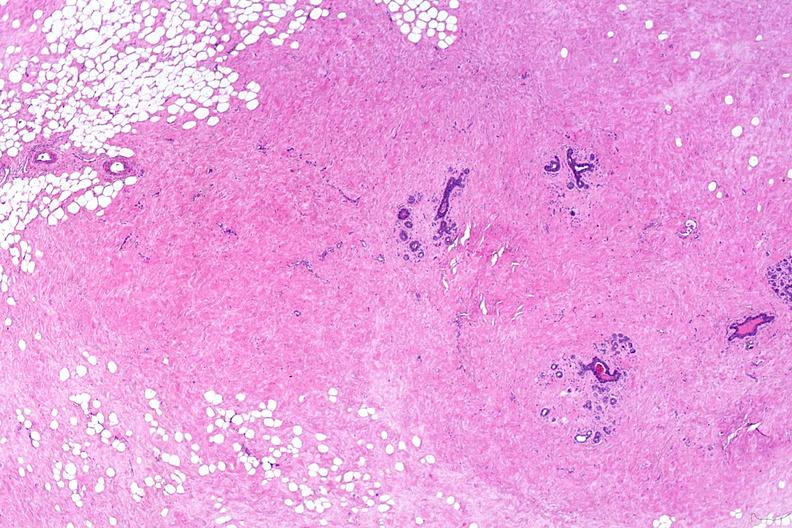s female reproductive present?
Answer the question using a single word or phrase. Yes 